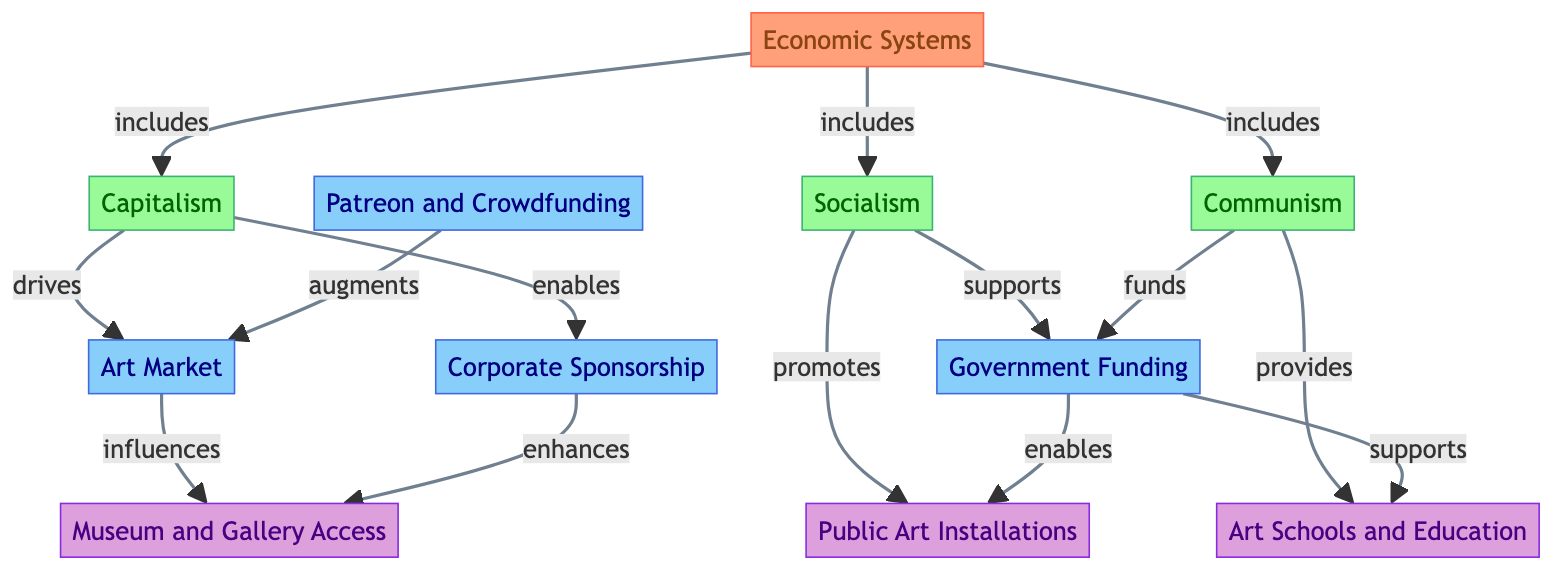What are the three economic systems represented in the diagram? The diagram lists three economic systems: Capitalism, Socialism, and Communism. These are seen as nodes directly connected to the main category of Economic Systems.
Answer: Capitalism, Socialism, Communism Which event is driven by Capitalism? According to the diagram, the Art Market is specifically mentioned as being driven by Capitalism. This connection is indicated by an arrow pointing from the Capitalism node to the Art Market node.
Answer: Art Market How many impacts are shown in the diagram? The diagram clearly presents four impacts related to cultural production and art access, which can be counted as nodes beneath the impact category.
Answer: 4 Which economic system supports Government Funding? The diagram indicates that Socialism supports Government Funding, represented by a direct connection (arrow) pointing to this event node from the Socialism node.
Answer: Socialism What enhances Museum and Gallery Access? Based on the diagram, Corporate Sponsorship enhances Museum and Gallery Access, as shown by the arrow connecting the Corporate Sponsorship node to the Museum and Gallery Access impact node.
Answer: Corporate Sponsorship How does Patreon and Crowdfunding relate to the Art Market? The diagram indicates that Patreon and Crowdfunding augments the Art Market, thus creating a supportive link between these two event nodes.
Answer: Augments Which impact is associated with both Government Funding and Socialism? The impact of Art Schools and Education is associated with both Government Funding and Socialism, as both of these categories direct an arrow towards the Art Schools and Education node.
Answer: Art Schools and Education What does Communism provide in terms of cultural production? According to the diagram, Communism provides Art Schools and Education, as indicated by the directional arrow pointing to this impact from the Communism node.
Answer: Art Schools and Education 